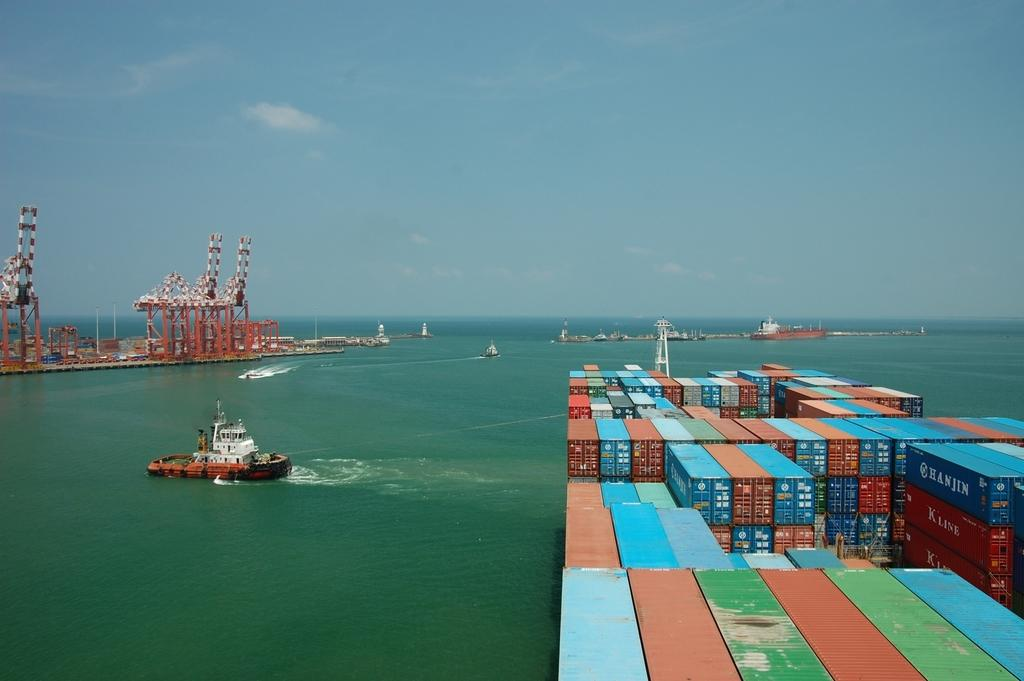What type of natural body of water is visible in the image? There is an ocean in the image. What can be seen on the right side of the image? Containers are present on the right side of the image. What color is the sky in the image? The sky is blue in color. What type of objects are on the left side of the image? There are metal things on the left side of the image. What event is taking place in the image involving a yoke? There is no event or yoke present in the image. 